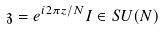<formula> <loc_0><loc_0><loc_500><loc_500>\mathfrak { z } = e ^ { i 2 \pi z / N } I \in S U ( N )</formula> 